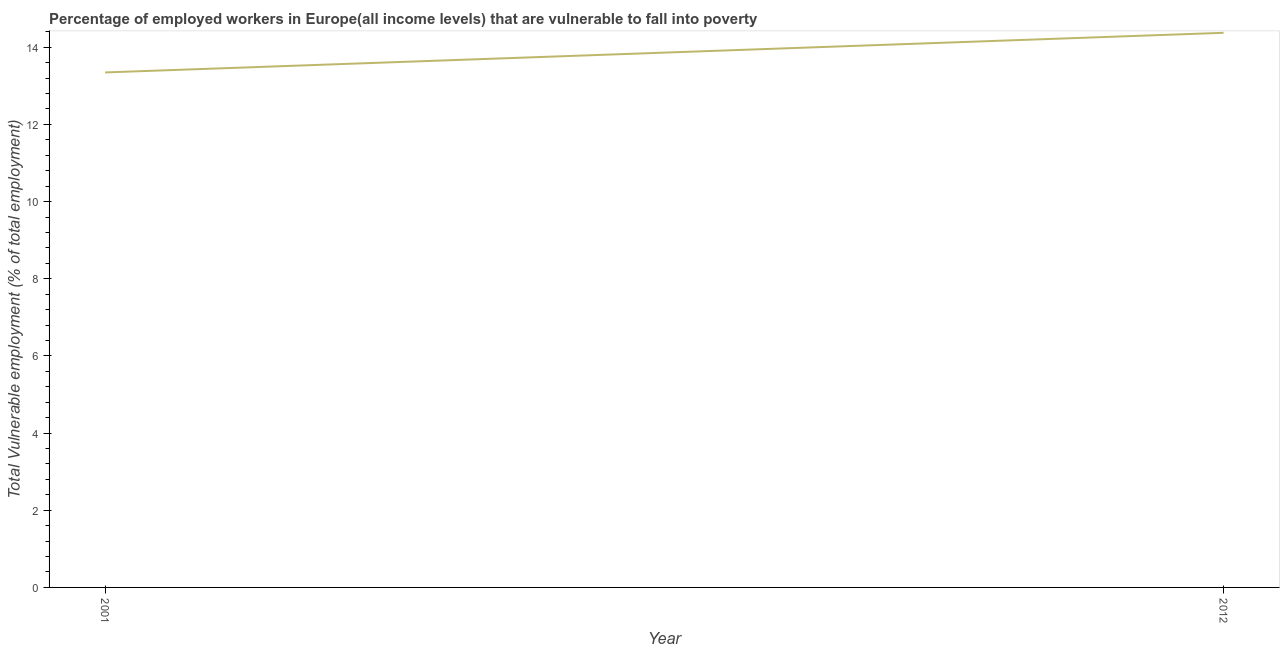What is the total vulnerable employment in 2012?
Your response must be concise. 14.37. Across all years, what is the maximum total vulnerable employment?
Provide a succinct answer. 14.37. Across all years, what is the minimum total vulnerable employment?
Your answer should be compact. 13.35. In which year was the total vulnerable employment maximum?
Keep it short and to the point. 2012. In which year was the total vulnerable employment minimum?
Your answer should be compact. 2001. What is the sum of the total vulnerable employment?
Keep it short and to the point. 27.72. What is the difference between the total vulnerable employment in 2001 and 2012?
Your answer should be very brief. -1.03. What is the average total vulnerable employment per year?
Your response must be concise. 13.86. What is the median total vulnerable employment?
Your response must be concise. 13.86. Do a majority of the years between 2001 and 2012 (inclusive) have total vulnerable employment greater than 10 %?
Offer a very short reply. Yes. What is the ratio of the total vulnerable employment in 2001 to that in 2012?
Offer a terse response. 0.93. Is the total vulnerable employment in 2001 less than that in 2012?
Make the answer very short. Yes. What is the title of the graph?
Your answer should be very brief. Percentage of employed workers in Europe(all income levels) that are vulnerable to fall into poverty. What is the label or title of the X-axis?
Provide a succinct answer. Year. What is the label or title of the Y-axis?
Offer a terse response. Total Vulnerable employment (% of total employment). What is the Total Vulnerable employment (% of total employment) of 2001?
Provide a succinct answer. 13.35. What is the Total Vulnerable employment (% of total employment) of 2012?
Your answer should be very brief. 14.37. What is the difference between the Total Vulnerable employment (% of total employment) in 2001 and 2012?
Offer a very short reply. -1.03. What is the ratio of the Total Vulnerable employment (% of total employment) in 2001 to that in 2012?
Keep it short and to the point. 0.93. 